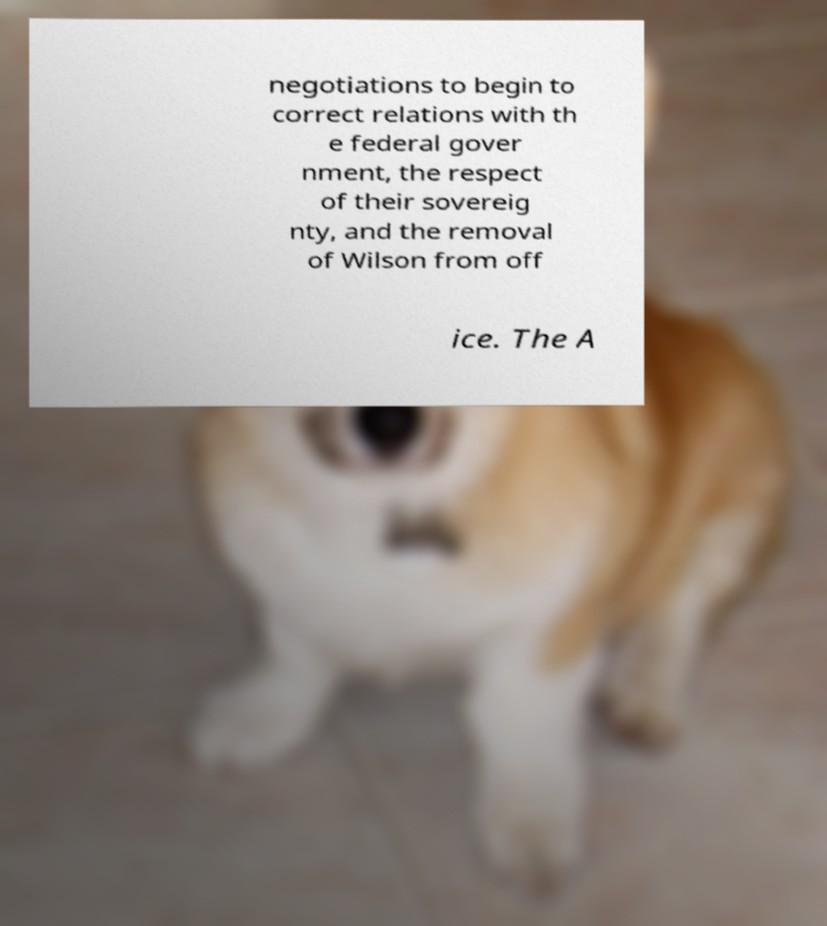Please identify and transcribe the text found in this image. negotiations to begin to correct relations with th e federal gover nment, the respect of their sovereig nty, and the removal of Wilson from off ice. The A 